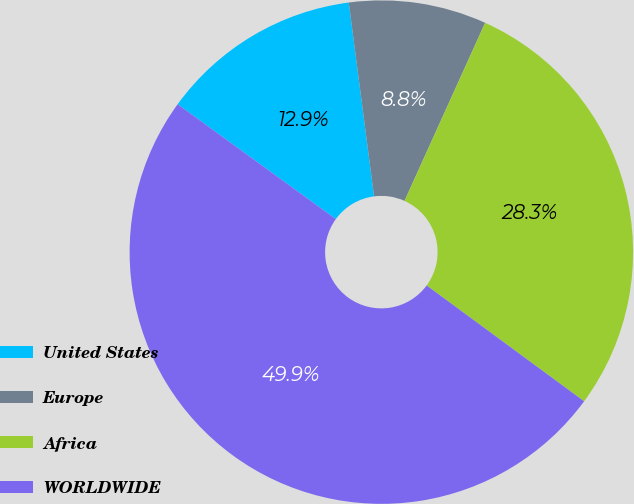Convert chart to OTSL. <chart><loc_0><loc_0><loc_500><loc_500><pie_chart><fcel>United States<fcel>Europe<fcel>Africa<fcel>WORLDWIDE<nl><fcel>12.94%<fcel>8.83%<fcel>28.33%<fcel>49.9%<nl></chart> 